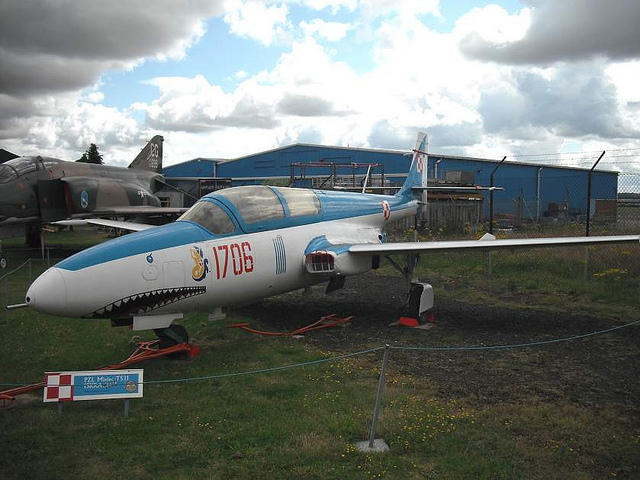Please transcribe the text information in this image. 1706 